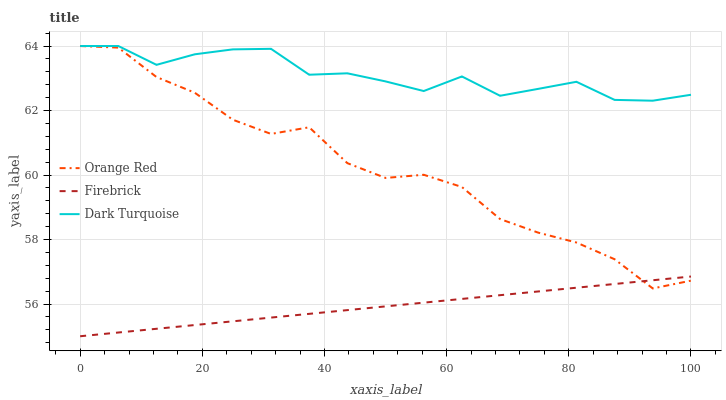Does Firebrick have the minimum area under the curve?
Answer yes or no. Yes. Does Dark Turquoise have the maximum area under the curve?
Answer yes or no. Yes. Does Orange Red have the minimum area under the curve?
Answer yes or no. No. Does Orange Red have the maximum area under the curve?
Answer yes or no. No. Is Firebrick the smoothest?
Answer yes or no. Yes. Is Orange Red the roughest?
Answer yes or no. Yes. Is Orange Red the smoothest?
Answer yes or no. No. Is Firebrick the roughest?
Answer yes or no. No. Does Firebrick have the lowest value?
Answer yes or no. Yes. Does Orange Red have the lowest value?
Answer yes or no. No. Does Orange Red have the highest value?
Answer yes or no. Yes. Does Firebrick have the highest value?
Answer yes or no. No. Is Firebrick less than Dark Turquoise?
Answer yes or no. Yes. Is Dark Turquoise greater than Firebrick?
Answer yes or no. Yes. Does Dark Turquoise intersect Orange Red?
Answer yes or no. Yes. Is Dark Turquoise less than Orange Red?
Answer yes or no. No. Is Dark Turquoise greater than Orange Red?
Answer yes or no. No. Does Firebrick intersect Dark Turquoise?
Answer yes or no. No. 